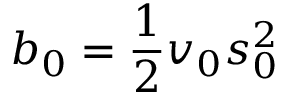Convert formula to latex. <formula><loc_0><loc_0><loc_500><loc_500>b _ { 0 } = { \frac { 1 } { 2 } } v _ { 0 } s _ { 0 } ^ { 2 }</formula> 